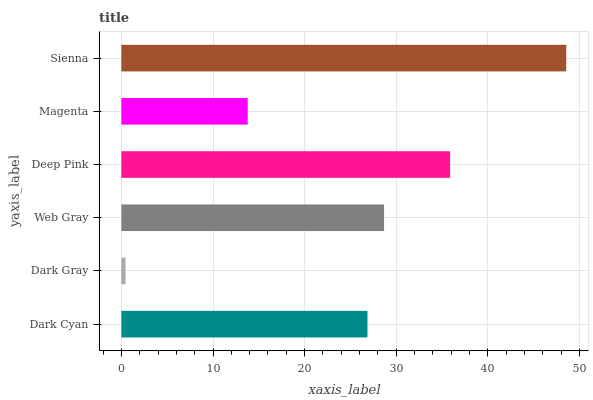Is Dark Gray the minimum?
Answer yes or no. Yes. Is Sienna the maximum?
Answer yes or no. Yes. Is Web Gray the minimum?
Answer yes or no. No. Is Web Gray the maximum?
Answer yes or no. No. Is Web Gray greater than Dark Gray?
Answer yes or no. Yes. Is Dark Gray less than Web Gray?
Answer yes or no. Yes. Is Dark Gray greater than Web Gray?
Answer yes or no. No. Is Web Gray less than Dark Gray?
Answer yes or no. No. Is Web Gray the high median?
Answer yes or no. Yes. Is Dark Cyan the low median?
Answer yes or no. Yes. Is Magenta the high median?
Answer yes or no. No. Is Web Gray the low median?
Answer yes or no. No. 